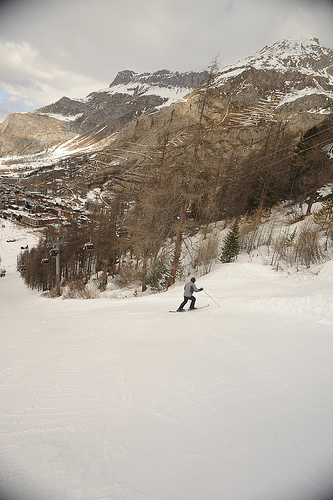What is the skier currently doing? The skier is carving a turn on a snowy slope, exhibiting good control and form as they navigate the terrain. 